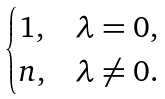<formula> <loc_0><loc_0><loc_500><loc_500>\begin{cases} 1 , & \lambda = 0 , \\ n , & \lambda \neq 0 . \end{cases}</formula> 